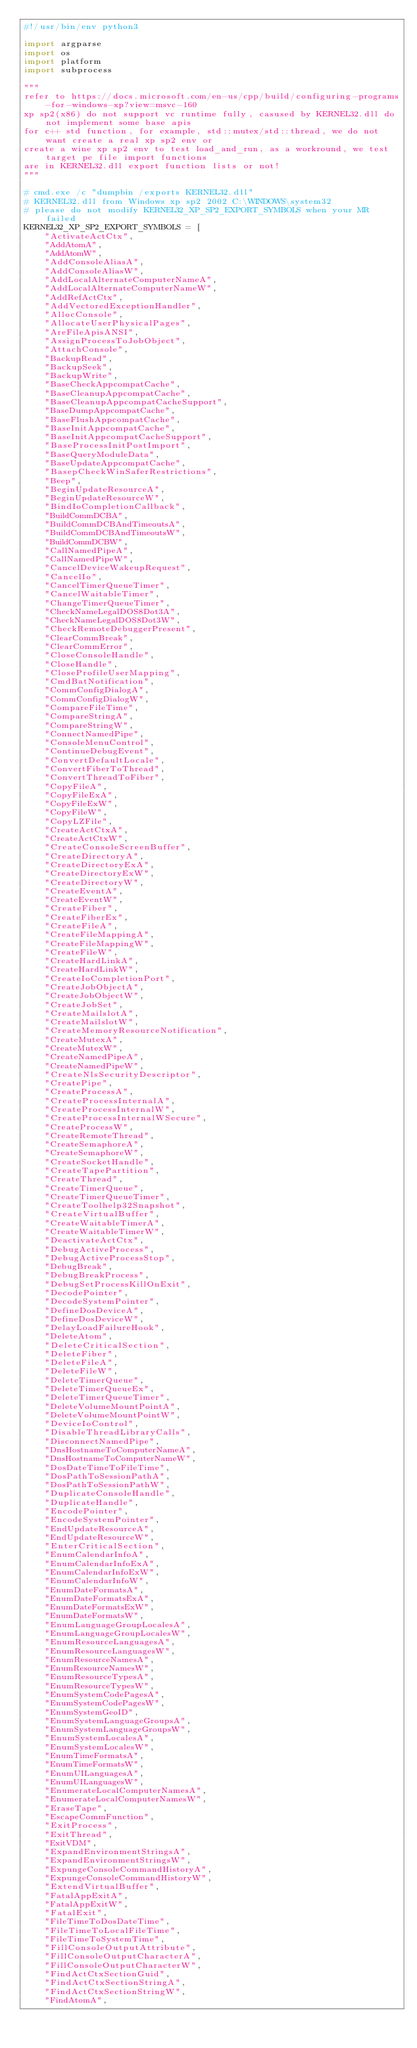Convert code to text. <code><loc_0><loc_0><loc_500><loc_500><_Python_>#!/usr/bin/env python3

import argparse
import os
import platform
import subprocess

"""
refer to https://docs.microsoft.com/en-us/cpp/build/configuring-programs-for-windows-xp?view=msvc-160
xp sp2(x86) do not support vc runtime fully, casused by KERNEL32.dll do not implement some base apis
for c++ std function, for example, std::mutex/std::thread, we do not want create a real xp sp2 env or
create a wine xp sp2 env to test load_and_run, as a workround, we test target pe file import functions
are in KERNEL32.dll export function lists or not!
"""

# cmd.exe /c "dumpbin /exports KERNEL32.dll"
# KERNEL32.dll from Windows xp sp2 2002 C:\WINDOWS\system32
# please do not modify KERNEL32_XP_SP2_EXPORT_SYMBOLS when your MR failed
KERNEL32_XP_SP2_EXPORT_SYMBOLS = [
    "ActivateActCtx",
    "AddAtomA",
    "AddAtomW",
    "AddConsoleAliasA",
    "AddConsoleAliasW",
    "AddLocalAlternateComputerNameA",
    "AddLocalAlternateComputerNameW",
    "AddRefActCtx",
    "AddVectoredExceptionHandler",
    "AllocConsole",
    "AllocateUserPhysicalPages",
    "AreFileApisANSI",
    "AssignProcessToJobObject",
    "AttachConsole",
    "BackupRead",
    "BackupSeek",
    "BackupWrite",
    "BaseCheckAppcompatCache",
    "BaseCleanupAppcompatCache",
    "BaseCleanupAppcompatCacheSupport",
    "BaseDumpAppcompatCache",
    "BaseFlushAppcompatCache",
    "BaseInitAppcompatCache",
    "BaseInitAppcompatCacheSupport",
    "BaseProcessInitPostImport",
    "BaseQueryModuleData",
    "BaseUpdateAppcompatCache",
    "BasepCheckWinSaferRestrictions",
    "Beep",
    "BeginUpdateResourceA",
    "BeginUpdateResourceW",
    "BindIoCompletionCallback",
    "BuildCommDCBA",
    "BuildCommDCBAndTimeoutsA",
    "BuildCommDCBAndTimeoutsW",
    "BuildCommDCBW",
    "CallNamedPipeA",
    "CallNamedPipeW",
    "CancelDeviceWakeupRequest",
    "CancelIo",
    "CancelTimerQueueTimer",
    "CancelWaitableTimer",
    "ChangeTimerQueueTimer",
    "CheckNameLegalDOS8Dot3A",
    "CheckNameLegalDOS8Dot3W",
    "CheckRemoteDebuggerPresent",
    "ClearCommBreak",
    "ClearCommError",
    "CloseConsoleHandle",
    "CloseHandle",
    "CloseProfileUserMapping",
    "CmdBatNotification",
    "CommConfigDialogA",
    "CommConfigDialogW",
    "CompareFileTime",
    "CompareStringA",
    "CompareStringW",
    "ConnectNamedPipe",
    "ConsoleMenuControl",
    "ContinueDebugEvent",
    "ConvertDefaultLocale",
    "ConvertFiberToThread",
    "ConvertThreadToFiber",
    "CopyFileA",
    "CopyFileExA",
    "CopyFileExW",
    "CopyFileW",
    "CopyLZFile",
    "CreateActCtxA",
    "CreateActCtxW",
    "CreateConsoleScreenBuffer",
    "CreateDirectoryA",
    "CreateDirectoryExA",
    "CreateDirectoryExW",
    "CreateDirectoryW",
    "CreateEventA",
    "CreateEventW",
    "CreateFiber",
    "CreateFiberEx",
    "CreateFileA",
    "CreateFileMappingA",
    "CreateFileMappingW",
    "CreateFileW",
    "CreateHardLinkA",
    "CreateHardLinkW",
    "CreateIoCompletionPort",
    "CreateJobObjectA",
    "CreateJobObjectW",
    "CreateJobSet",
    "CreateMailslotA",
    "CreateMailslotW",
    "CreateMemoryResourceNotification",
    "CreateMutexA",
    "CreateMutexW",
    "CreateNamedPipeA",
    "CreateNamedPipeW",
    "CreateNlsSecurityDescriptor",
    "CreatePipe",
    "CreateProcessA",
    "CreateProcessInternalA",
    "CreateProcessInternalW",
    "CreateProcessInternalWSecure",
    "CreateProcessW",
    "CreateRemoteThread",
    "CreateSemaphoreA",
    "CreateSemaphoreW",
    "CreateSocketHandle",
    "CreateTapePartition",
    "CreateThread",
    "CreateTimerQueue",
    "CreateTimerQueueTimer",
    "CreateToolhelp32Snapshot",
    "CreateVirtualBuffer",
    "CreateWaitableTimerA",
    "CreateWaitableTimerW",
    "DeactivateActCtx",
    "DebugActiveProcess",
    "DebugActiveProcessStop",
    "DebugBreak",
    "DebugBreakProcess",
    "DebugSetProcessKillOnExit",
    "DecodePointer",
    "DecodeSystemPointer",
    "DefineDosDeviceA",
    "DefineDosDeviceW",
    "DelayLoadFailureHook",
    "DeleteAtom",
    "DeleteCriticalSection",
    "DeleteFiber",
    "DeleteFileA",
    "DeleteFileW",
    "DeleteTimerQueue",
    "DeleteTimerQueueEx",
    "DeleteTimerQueueTimer",
    "DeleteVolumeMountPointA",
    "DeleteVolumeMountPointW",
    "DeviceIoControl",
    "DisableThreadLibraryCalls",
    "DisconnectNamedPipe",
    "DnsHostnameToComputerNameA",
    "DnsHostnameToComputerNameW",
    "DosDateTimeToFileTime",
    "DosPathToSessionPathA",
    "DosPathToSessionPathW",
    "DuplicateConsoleHandle",
    "DuplicateHandle",
    "EncodePointer",
    "EncodeSystemPointer",
    "EndUpdateResourceA",
    "EndUpdateResourceW",
    "EnterCriticalSection",
    "EnumCalendarInfoA",
    "EnumCalendarInfoExA",
    "EnumCalendarInfoExW",
    "EnumCalendarInfoW",
    "EnumDateFormatsA",
    "EnumDateFormatsExA",
    "EnumDateFormatsExW",
    "EnumDateFormatsW",
    "EnumLanguageGroupLocalesA",
    "EnumLanguageGroupLocalesW",
    "EnumResourceLanguagesA",
    "EnumResourceLanguagesW",
    "EnumResourceNamesA",
    "EnumResourceNamesW",
    "EnumResourceTypesA",
    "EnumResourceTypesW",
    "EnumSystemCodePagesA",
    "EnumSystemCodePagesW",
    "EnumSystemGeoID",
    "EnumSystemLanguageGroupsA",
    "EnumSystemLanguageGroupsW",
    "EnumSystemLocalesA",
    "EnumSystemLocalesW",
    "EnumTimeFormatsA",
    "EnumTimeFormatsW",
    "EnumUILanguagesA",
    "EnumUILanguagesW",
    "EnumerateLocalComputerNamesA",
    "EnumerateLocalComputerNamesW",
    "EraseTape",
    "EscapeCommFunction",
    "ExitProcess",
    "ExitThread",
    "ExitVDM",
    "ExpandEnvironmentStringsA",
    "ExpandEnvironmentStringsW",
    "ExpungeConsoleCommandHistoryA",
    "ExpungeConsoleCommandHistoryW",
    "ExtendVirtualBuffer",
    "FatalAppExitA",
    "FatalAppExitW",
    "FatalExit",
    "FileTimeToDosDateTime",
    "FileTimeToLocalFileTime",
    "FileTimeToSystemTime",
    "FillConsoleOutputAttribute",
    "FillConsoleOutputCharacterA",
    "FillConsoleOutputCharacterW",
    "FindActCtxSectionGuid",
    "FindActCtxSectionStringA",
    "FindActCtxSectionStringW",
    "FindAtomA",</code> 